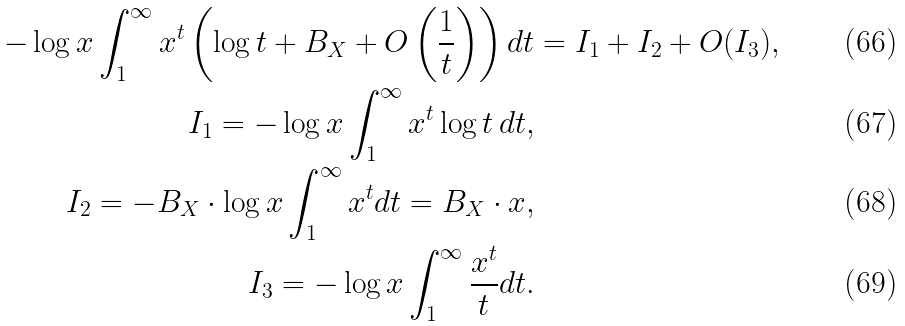Convert formula to latex. <formula><loc_0><loc_0><loc_500><loc_500>- \log x \int _ { 1 } ^ { \infty } x ^ { t } \left ( \log t + B _ { X } + O \left ( \frac { 1 } { t } \right ) \right ) d t & = I _ { 1 } + I _ { 2 } + O ( I _ { 3 } ) , \\ I _ { 1 } = - \log x \int _ { 1 } ^ { \infty } x ^ { t } \log t \, d t , & \\ I _ { 2 } = - B _ { X } \cdot \log x \int _ { 1 } ^ { \infty } x ^ { t } d t = B _ { X } \cdot x , & \\ I _ { 3 } = - \log x \int _ { 1 } ^ { \infty } \frac { x ^ { t } } { t } d t . &</formula> 